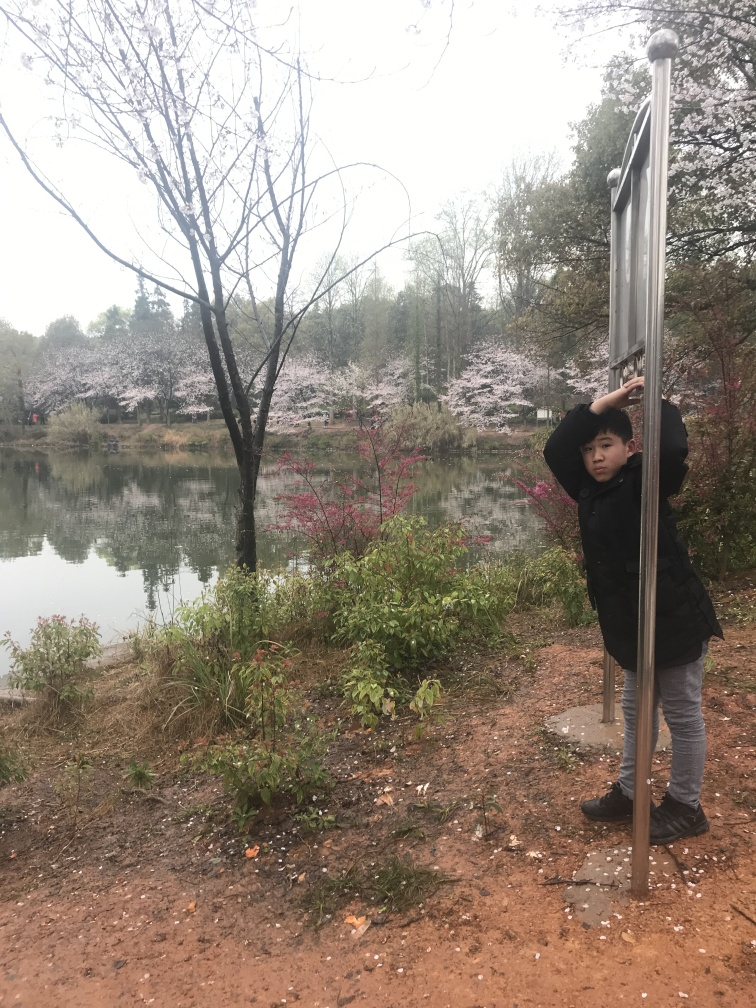What time of year does this photo suggest, and why? The photo suggests early spring as evidenced by the blooming cherry blossom trees, which are iconic in this season. The trees are abundant with fresh pink blossoms, but the absence of full foliage on other trees indicates that winter has only recently ended. Additionally, the person's attire, which includes a coat, suggests that it's still cool outside, typical of spring's temperate climates. 